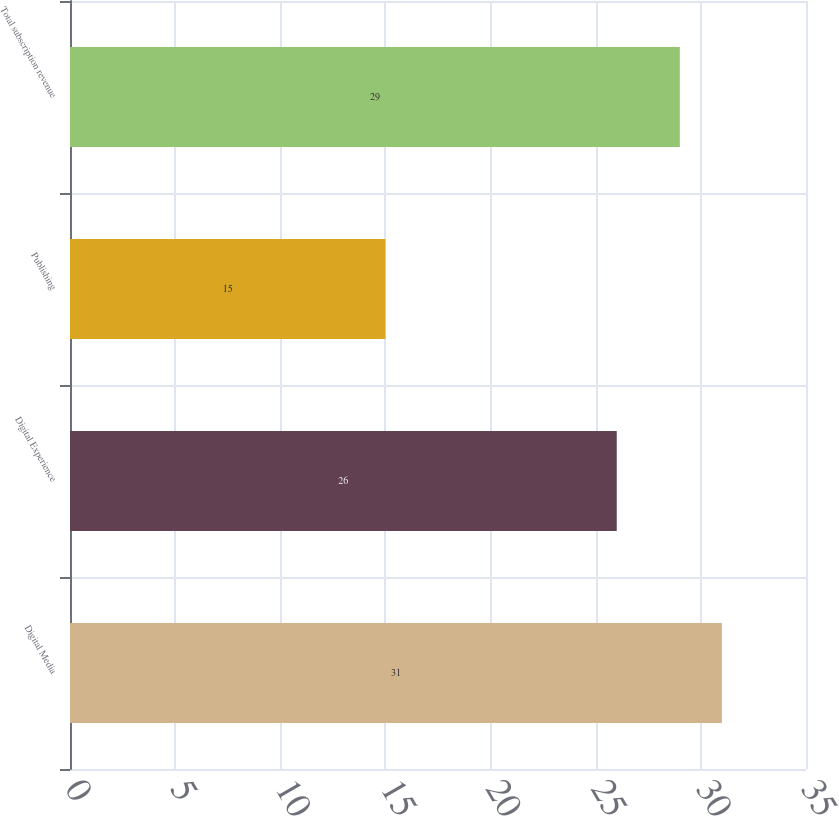Convert chart. <chart><loc_0><loc_0><loc_500><loc_500><bar_chart><fcel>Digital Media<fcel>Digital Experience<fcel>Publishing<fcel>Total subscription revenue<nl><fcel>31<fcel>26<fcel>15<fcel>29<nl></chart> 